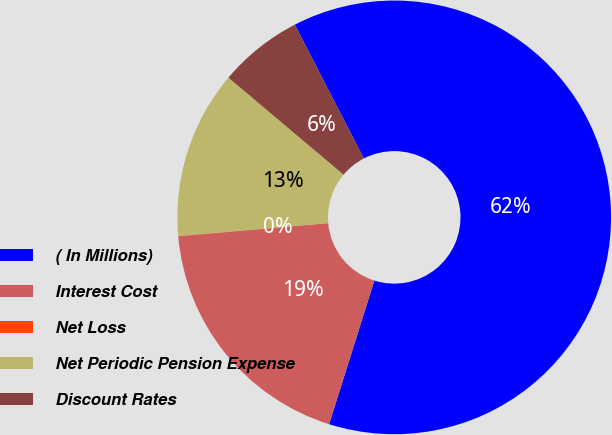Convert chart. <chart><loc_0><loc_0><loc_500><loc_500><pie_chart><fcel>( In Millions)<fcel>Interest Cost<fcel>Net Loss<fcel>Net Periodic Pension Expense<fcel>Discount Rates<nl><fcel>62.44%<fcel>18.75%<fcel>0.03%<fcel>12.51%<fcel>6.27%<nl></chart> 